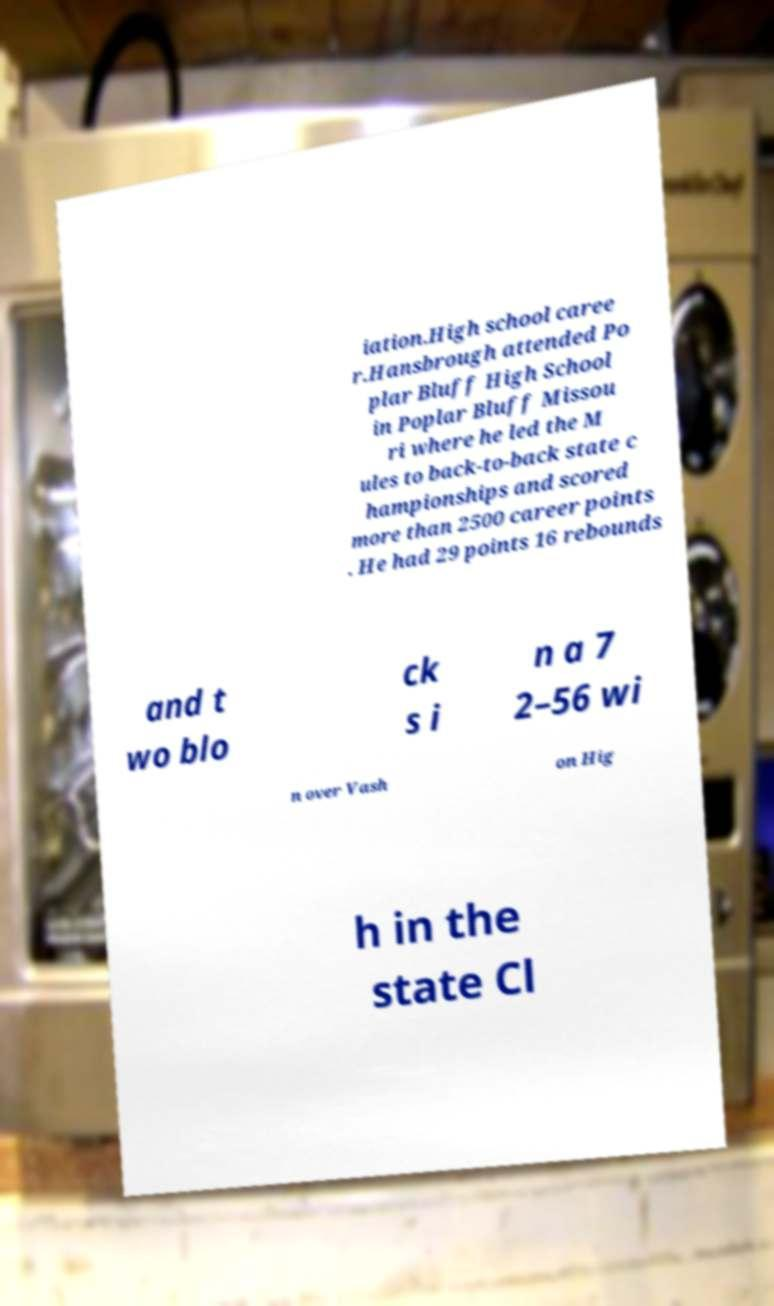Can you accurately transcribe the text from the provided image for me? iation.High school caree r.Hansbrough attended Po plar Bluff High School in Poplar Bluff Missou ri where he led the M ules to back-to-back state c hampionships and scored more than 2500 career points . He had 29 points 16 rebounds and t wo blo ck s i n a 7 2–56 wi n over Vash on Hig h in the state Cl 